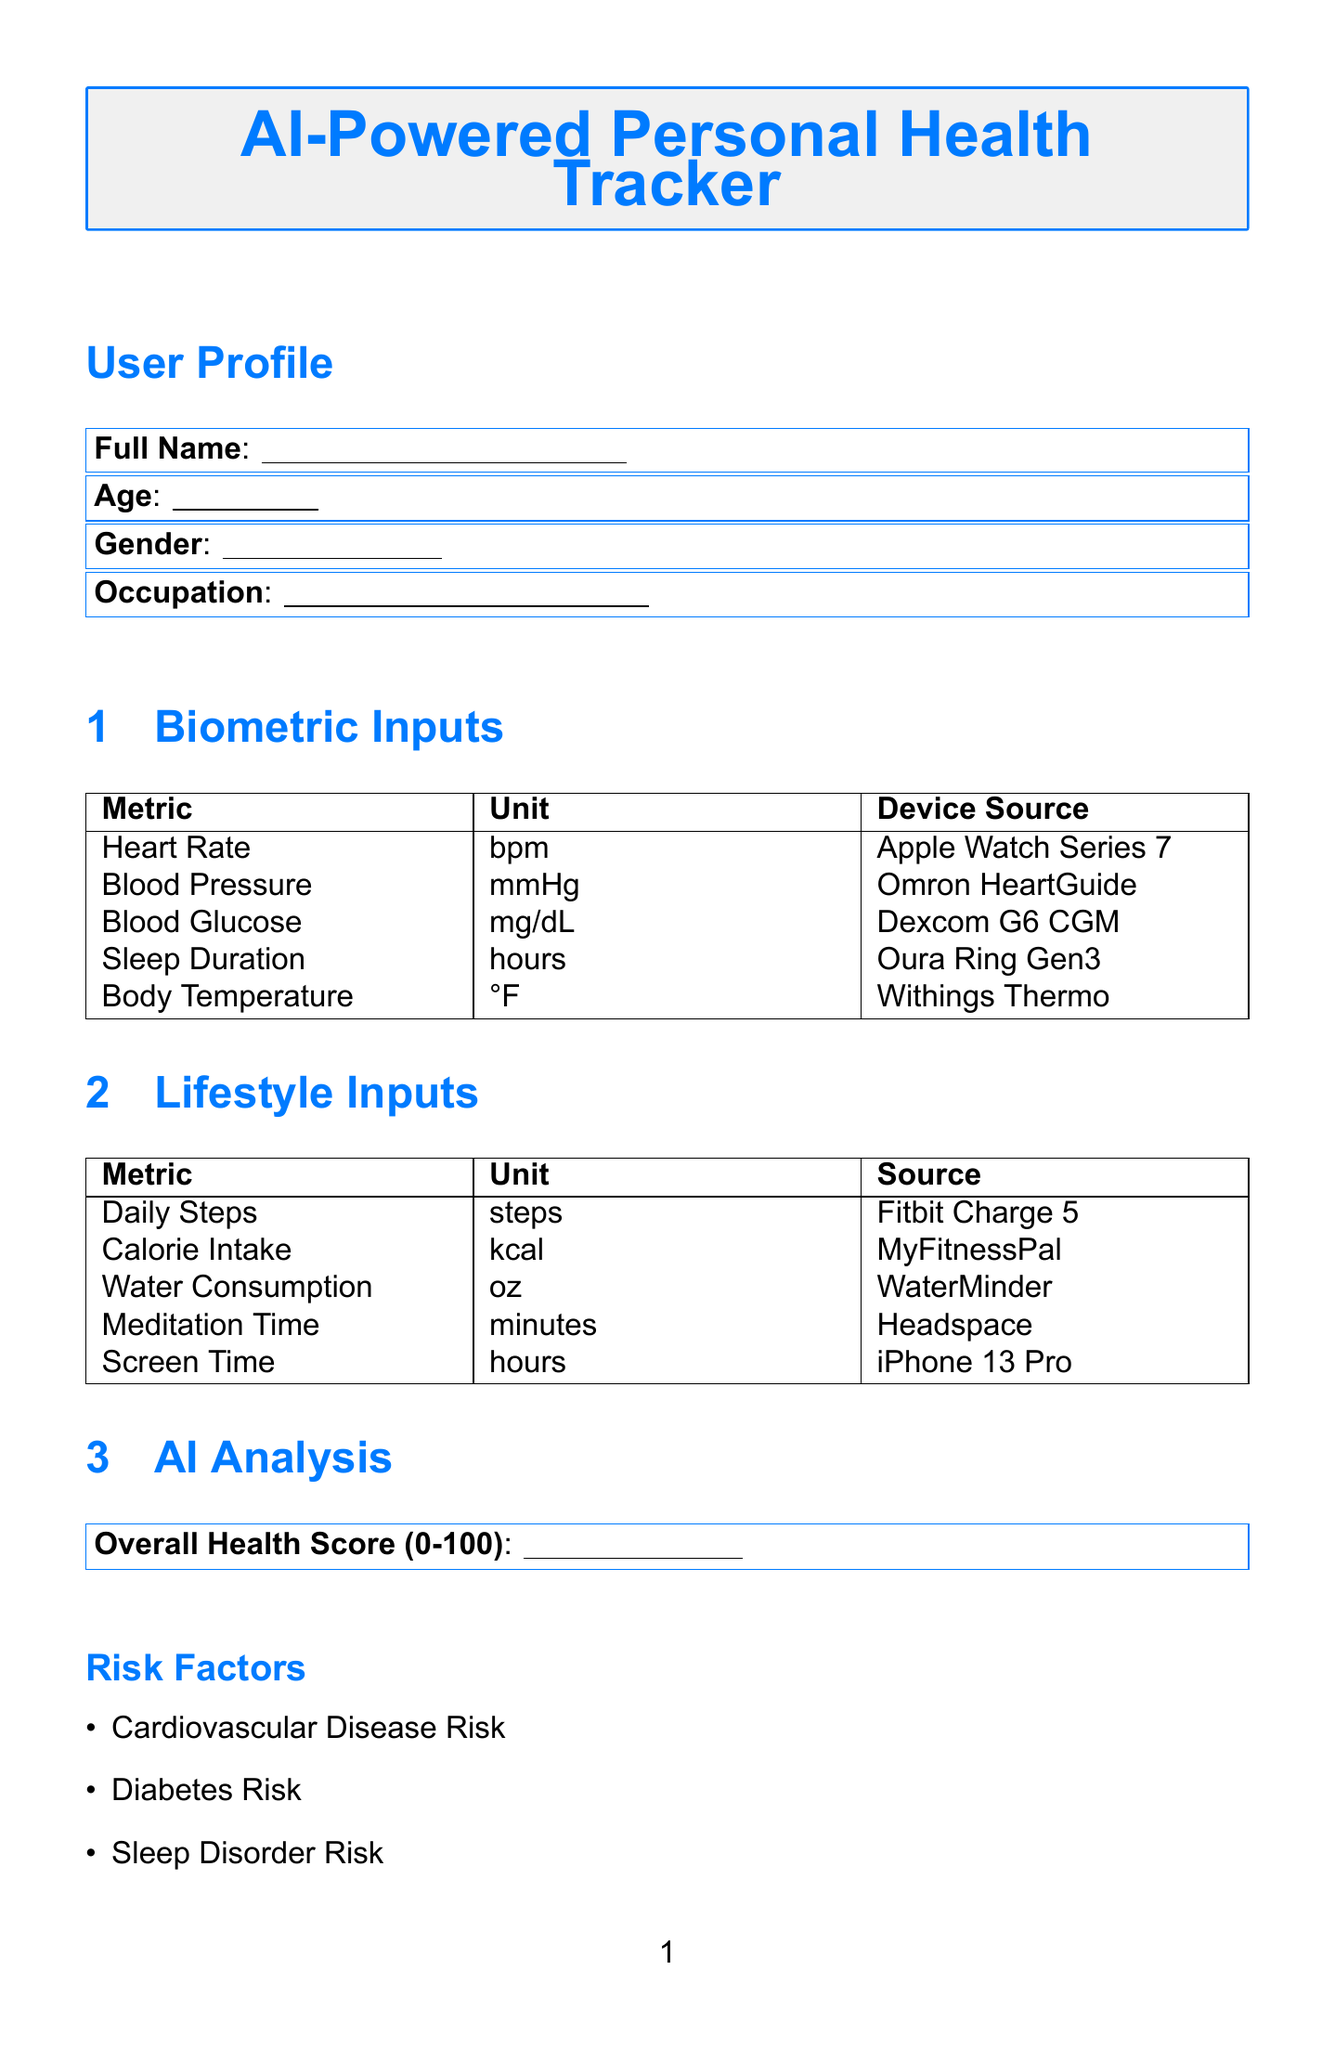what is the title of the form? The title of the form is explicitly stated at the beginning of the document.
Answer: AI-Powered Personal Health Tracker who is the model named in the AI model information section? The model name is provided in the table detailing the AI model information.
Answer: HealthAI Pro what is the accuracy rate of the AI model? The accuracy rate is mentioned in the AI model information table.
Answer: 98.7% how many lifestyle inputs are listed in the document? The document lists the number of lifestyle inputs in the corresponding section.
Answer: 5 which wearable device is specified for monitoring sleep duration? The device source for sleep duration is clearly identified in the biometric inputs section.
Answer: Oura Ring Gen3 what health score range is indicated in the AI analysis section? The health score range is mentioned specifically in the AI analysis section of the document.
Answer: 0-100 name one recommendation under the Fitness category. The recommendations under the Fitness category are listed in a designated box.
Answer: AI-generated workout routines what feature is provided for stress management? A specific suggestion for managing stress is included in the recommendations section under Mental Health.
Answer: Stress management techniques 